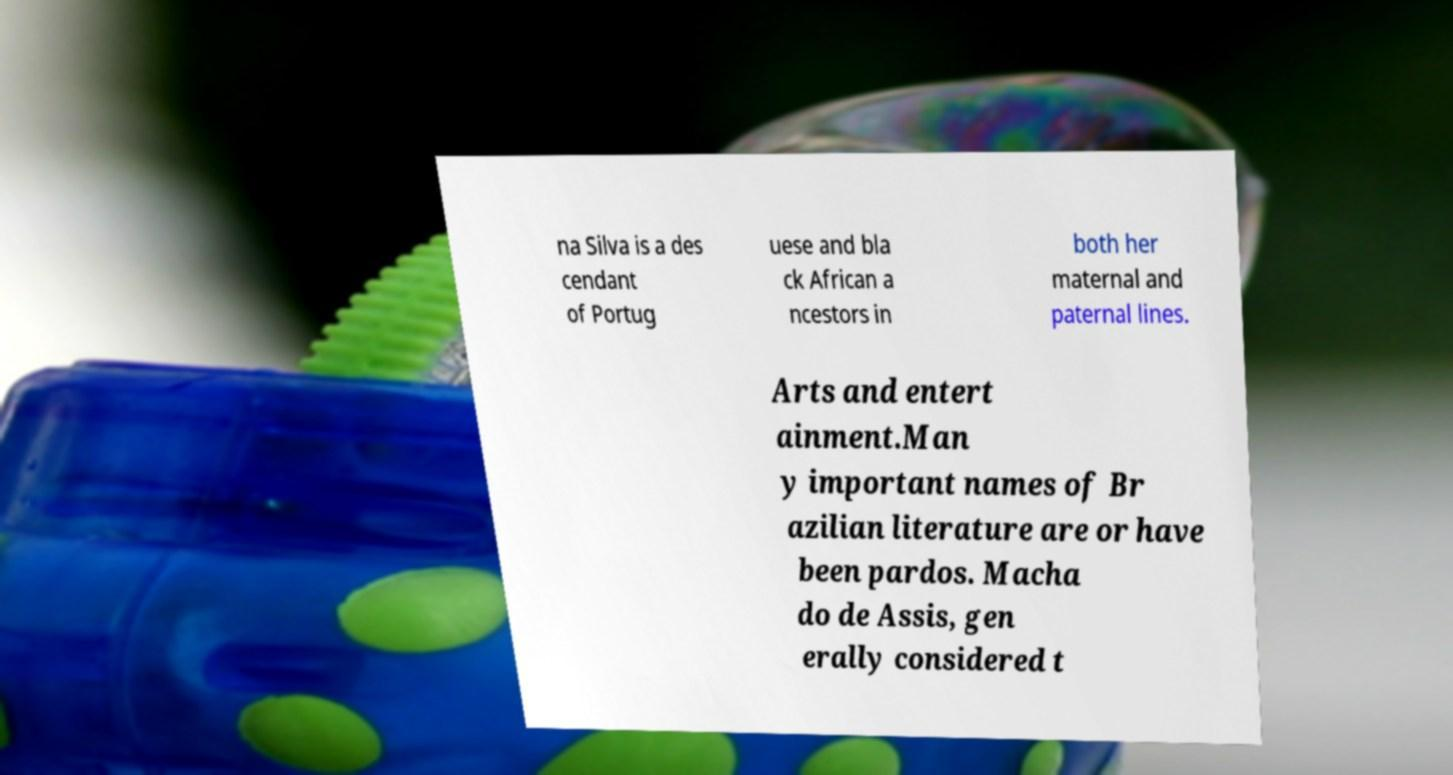What messages or text are displayed in this image? I need them in a readable, typed format. na Silva is a des cendant of Portug uese and bla ck African a ncestors in both her maternal and paternal lines. Arts and entert ainment.Man y important names of Br azilian literature are or have been pardos. Macha do de Assis, gen erally considered t 